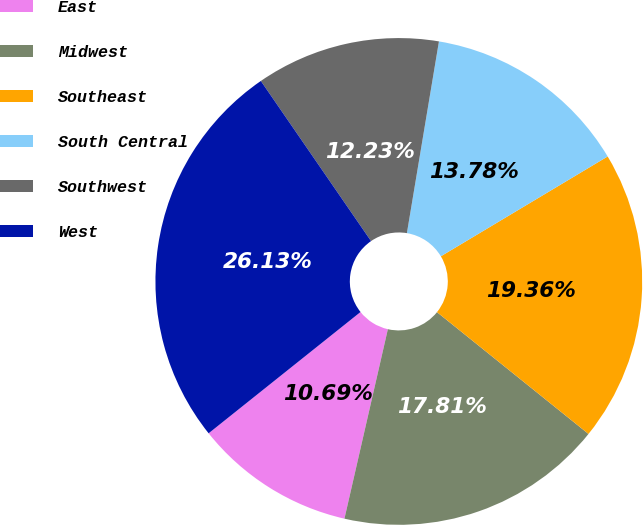Convert chart. <chart><loc_0><loc_0><loc_500><loc_500><pie_chart><fcel>East<fcel>Midwest<fcel>Southeast<fcel>South Central<fcel>Southwest<fcel>West<nl><fcel>10.69%<fcel>17.81%<fcel>19.36%<fcel>13.78%<fcel>12.23%<fcel>26.13%<nl></chart> 